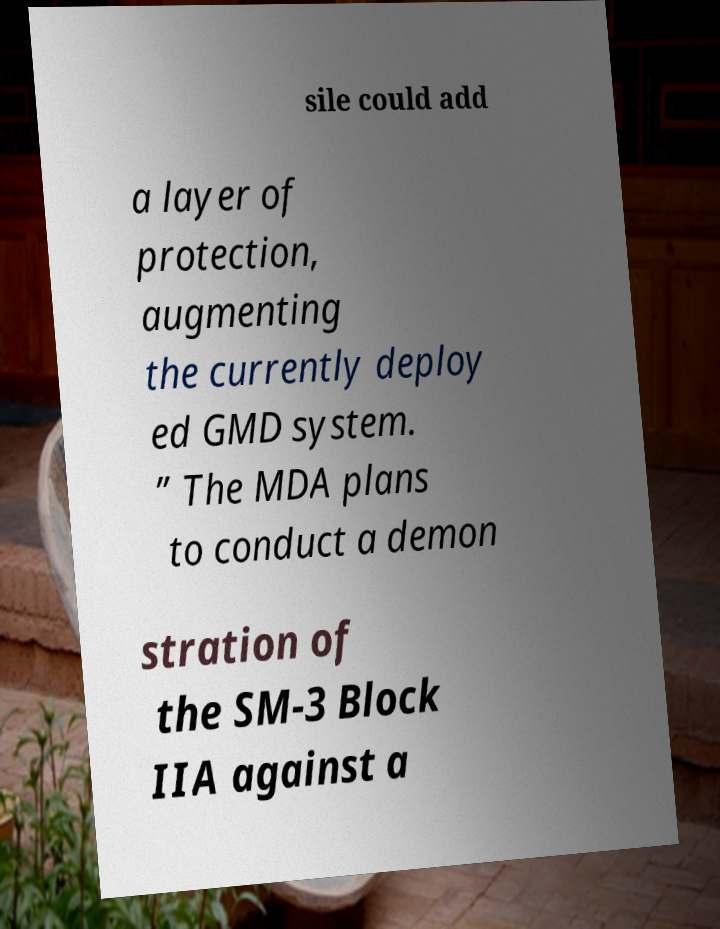Please identify and transcribe the text found in this image. sile could add a layer of protection, augmenting the currently deploy ed GMD system. ” The MDA plans to conduct a demon stration of the SM-3 Block IIA against a 